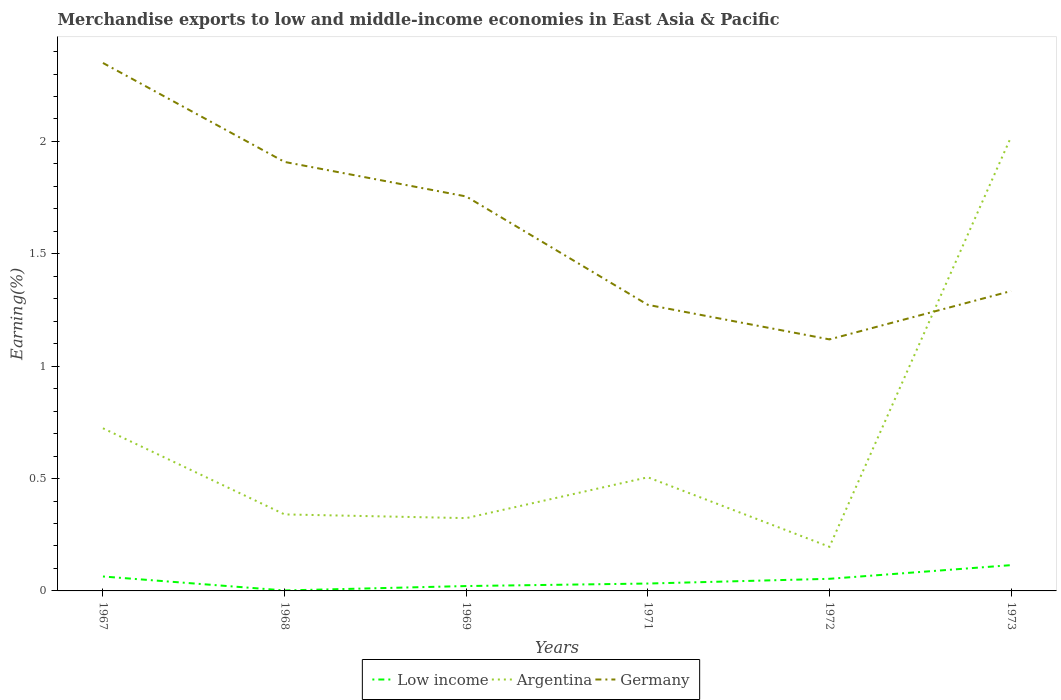Does the line corresponding to Argentina intersect with the line corresponding to Low income?
Make the answer very short. No. Is the number of lines equal to the number of legend labels?
Provide a succinct answer. Yes. Across all years, what is the maximum percentage of amount earned from merchandise exports in Germany?
Provide a short and direct response. 1.12. In which year was the percentage of amount earned from merchandise exports in Low income maximum?
Offer a terse response. 1968. What is the total percentage of amount earned from merchandise exports in Argentina in the graph?
Keep it short and to the point. -0.17. What is the difference between the highest and the second highest percentage of amount earned from merchandise exports in Argentina?
Your response must be concise. 1.82. What is the difference between the highest and the lowest percentage of amount earned from merchandise exports in Argentina?
Make the answer very short. 2. Is the percentage of amount earned from merchandise exports in Germany strictly greater than the percentage of amount earned from merchandise exports in Low income over the years?
Your answer should be very brief. No. How many lines are there?
Offer a very short reply. 3. Does the graph contain grids?
Keep it short and to the point. No. Where does the legend appear in the graph?
Offer a very short reply. Bottom center. What is the title of the graph?
Your answer should be very brief. Merchandise exports to low and middle-income economies in East Asia & Pacific. What is the label or title of the Y-axis?
Offer a terse response. Earning(%). What is the Earning(%) in Low income in 1967?
Keep it short and to the point. 0.06. What is the Earning(%) in Argentina in 1967?
Keep it short and to the point. 0.72. What is the Earning(%) of Germany in 1967?
Give a very brief answer. 2.35. What is the Earning(%) of Low income in 1968?
Provide a succinct answer. 0. What is the Earning(%) in Argentina in 1968?
Keep it short and to the point. 0.34. What is the Earning(%) of Germany in 1968?
Your response must be concise. 1.91. What is the Earning(%) in Low income in 1969?
Provide a succinct answer. 0.02. What is the Earning(%) of Argentina in 1969?
Keep it short and to the point. 0.32. What is the Earning(%) in Germany in 1969?
Keep it short and to the point. 1.76. What is the Earning(%) in Low income in 1971?
Offer a very short reply. 0.03. What is the Earning(%) in Argentina in 1971?
Ensure brevity in your answer.  0.51. What is the Earning(%) in Germany in 1971?
Your answer should be very brief. 1.27. What is the Earning(%) in Low income in 1972?
Provide a short and direct response. 0.05. What is the Earning(%) in Argentina in 1972?
Provide a succinct answer. 0.2. What is the Earning(%) in Germany in 1972?
Give a very brief answer. 1.12. What is the Earning(%) of Low income in 1973?
Provide a succinct answer. 0.11. What is the Earning(%) of Argentina in 1973?
Offer a terse response. 2.02. What is the Earning(%) in Germany in 1973?
Give a very brief answer. 1.33. Across all years, what is the maximum Earning(%) of Low income?
Ensure brevity in your answer.  0.11. Across all years, what is the maximum Earning(%) of Argentina?
Keep it short and to the point. 2.02. Across all years, what is the maximum Earning(%) of Germany?
Your answer should be compact. 2.35. Across all years, what is the minimum Earning(%) in Low income?
Ensure brevity in your answer.  0. Across all years, what is the minimum Earning(%) in Argentina?
Offer a terse response. 0.2. Across all years, what is the minimum Earning(%) of Germany?
Offer a very short reply. 1.12. What is the total Earning(%) of Low income in the graph?
Your answer should be compact. 0.29. What is the total Earning(%) in Argentina in the graph?
Your response must be concise. 4.11. What is the total Earning(%) of Germany in the graph?
Your answer should be very brief. 9.74. What is the difference between the Earning(%) of Low income in 1967 and that in 1968?
Keep it short and to the point. 0.06. What is the difference between the Earning(%) of Argentina in 1967 and that in 1968?
Provide a short and direct response. 0.38. What is the difference between the Earning(%) in Germany in 1967 and that in 1968?
Keep it short and to the point. 0.44. What is the difference between the Earning(%) in Low income in 1967 and that in 1969?
Your answer should be compact. 0.04. What is the difference between the Earning(%) in Argentina in 1967 and that in 1969?
Ensure brevity in your answer.  0.4. What is the difference between the Earning(%) in Germany in 1967 and that in 1969?
Provide a succinct answer. 0.59. What is the difference between the Earning(%) in Low income in 1967 and that in 1971?
Provide a short and direct response. 0.03. What is the difference between the Earning(%) of Argentina in 1967 and that in 1971?
Your answer should be very brief. 0.22. What is the difference between the Earning(%) of Germany in 1967 and that in 1971?
Offer a terse response. 1.08. What is the difference between the Earning(%) in Low income in 1967 and that in 1972?
Your answer should be very brief. 0.01. What is the difference between the Earning(%) of Argentina in 1967 and that in 1972?
Your answer should be very brief. 0.53. What is the difference between the Earning(%) in Germany in 1967 and that in 1972?
Provide a succinct answer. 1.23. What is the difference between the Earning(%) in Low income in 1967 and that in 1973?
Offer a very short reply. -0.05. What is the difference between the Earning(%) of Argentina in 1967 and that in 1973?
Offer a terse response. -1.3. What is the difference between the Earning(%) of Germany in 1967 and that in 1973?
Your answer should be very brief. 1.01. What is the difference between the Earning(%) in Low income in 1968 and that in 1969?
Your answer should be very brief. -0.02. What is the difference between the Earning(%) in Argentina in 1968 and that in 1969?
Your answer should be very brief. 0.02. What is the difference between the Earning(%) of Germany in 1968 and that in 1969?
Provide a short and direct response. 0.15. What is the difference between the Earning(%) of Low income in 1968 and that in 1971?
Offer a terse response. -0.03. What is the difference between the Earning(%) in Argentina in 1968 and that in 1971?
Your response must be concise. -0.17. What is the difference between the Earning(%) in Germany in 1968 and that in 1971?
Provide a succinct answer. 0.64. What is the difference between the Earning(%) of Low income in 1968 and that in 1972?
Provide a short and direct response. -0.05. What is the difference between the Earning(%) in Argentina in 1968 and that in 1972?
Offer a terse response. 0.14. What is the difference between the Earning(%) of Germany in 1968 and that in 1972?
Keep it short and to the point. 0.79. What is the difference between the Earning(%) of Low income in 1968 and that in 1973?
Make the answer very short. -0.11. What is the difference between the Earning(%) of Argentina in 1968 and that in 1973?
Offer a very short reply. -1.68. What is the difference between the Earning(%) in Germany in 1968 and that in 1973?
Your answer should be very brief. 0.57. What is the difference between the Earning(%) of Low income in 1969 and that in 1971?
Offer a very short reply. -0.01. What is the difference between the Earning(%) in Argentina in 1969 and that in 1971?
Make the answer very short. -0.18. What is the difference between the Earning(%) in Germany in 1969 and that in 1971?
Ensure brevity in your answer.  0.48. What is the difference between the Earning(%) in Low income in 1969 and that in 1972?
Your answer should be compact. -0.03. What is the difference between the Earning(%) in Argentina in 1969 and that in 1972?
Provide a succinct answer. 0.13. What is the difference between the Earning(%) in Germany in 1969 and that in 1972?
Your response must be concise. 0.64. What is the difference between the Earning(%) of Low income in 1969 and that in 1973?
Your response must be concise. -0.09. What is the difference between the Earning(%) in Argentina in 1969 and that in 1973?
Provide a short and direct response. -1.7. What is the difference between the Earning(%) in Germany in 1969 and that in 1973?
Give a very brief answer. 0.42. What is the difference between the Earning(%) in Low income in 1971 and that in 1972?
Give a very brief answer. -0.02. What is the difference between the Earning(%) of Argentina in 1971 and that in 1972?
Your answer should be very brief. 0.31. What is the difference between the Earning(%) of Germany in 1971 and that in 1972?
Your response must be concise. 0.15. What is the difference between the Earning(%) in Low income in 1971 and that in 1973?
Offer a very short reply. -0.08. What is the difference between the Earning(%) of Argentina in 1971 and that in 1973?
Give a very brief answer. -1.51. What is the difference between the Earning(%) of Germany in 1971 and that in 1973?
Make the answer very short. -0.06. What is the difference between the Earning(%) of Low income in 1972 and that in 1973?
Ensure brevity in your answer.  -0.06. What is the difference between the Earning(%) in Argentina in 1972 and that in 1973?
Your answer should be compact. -1.82. What is the difference between the Earning(%) of Germany in 1972 and that in 1973?
Make the answer very short. -0.22. What is the difference between the Earning(%) in Low income in 1967 and the Earning(%) in Argentina in 1968?
Ensure brevity in your answer.  -0.28. What is the difference between the Earning(%) in Low income in 1967 and the Earning(%) in Germany in 1968?
Your response must be concise. -1.84. What is the difference between the Earning(%) in Argentina in 1967 and the Earning(%) in Germany in 1968?
Make the answer very short. -1.19. What is the difference between the Earning(%) of Low income in 1967 and the Earning(%) of Argentina in 1969?
Keep it short and to the point. -0.26. What is the difference between the Earning(%) in Low income in 1967 and the Earning(%) in Germany in 1969?
Ensure brevity in your answer.  -1.69. What is the difference between the Earning(%) of Argentina in 1967 and the Earning(%) of Germany in 1969?
Make the answer very short. -1.03. What is the difference between the Earning(%) of Low income in 1967 and the Earning(%) of Argentina in 1971?
Give a very brief answer. -0.44. What is the difference between the Earning(%) in Low income in 1967 and the Earning(%) in Germany in 1971?
Give a very brief answer. -1.21. What is the difference between the Earning(%) of Argentina in 1967 and the Earning(%) of Germany in 1971?
Your response must be concise. -0.55. What is the difference between the Earning(%) of Low income in 1967 and the Earning(%) of Argentina in 1972?
Your answer should be very brief. -0.13. What is the difference between the Earning(%) in Low income in 1967 and the Earning(%) in Germany in 1972?
Your answer should be compact. -1.05. What is the difference between the Earning(%) of Argentina in 1967 and the Earning(%) of Germany in 1972?
Make the answer very short. -0.4. What is the difference between the Earning(%) of Low income in 1967 and the Earning(%) of Argentina in 1973?
Offer a terse response. -1.96. What is the difference between the Earning(%) in Low income in 1967 and the Earning(%) in Germany in 1973?
Make the answer very short. -1.27. What is the difference between the Earning(%) of Argentina in 1967 and the Earning(%) of Germany in 1973?
Provide a short and direct response. -0.61. What is the difference between the Earning(%) in Low income in 1968 and the Earning(%) in Argentina in 1969?
Your response must be concise. -0.32. What is the difference between the Earning(%) in Low income in 1968 and the Earning(%) in Germany in 1969?
Ensure brevity in your answer.  -1.75. What is the difference between the Earning(%) of Argentina in 1968 and the Earning(%) of Germany in 1969?
Your answer should be compact. -1.41. What is the difference between the Earning(%) of Low income in 1968 and the Earning(%) of Argentina in 1971?
Ensure brevity in your answer.  -0.5. What is the difference between the Earning(%) in Low income in 1968 and the Earning(%) in Germany in 1971?
Give a very brief answer. -1.27. What is the difference between the Earning(%) of Argentina in 1968 and the Earning(%) of Germany in 1971?
Your answer should be compact. -0.93. What is the difference between the Earning(%) of Low income in 1968 and the Earning(%) of Argentina in 1972?
Your answer should be compact. -0.19. What is the difference between the Earning(%) in Low income in 1968 and the Earning(%) in Germany in 1972?
Offer a terse response. -1.12. What is the difference between the Earning(%) of Argentina in 1968 and the Earning(%) of Germany in 1972?
Offer a very short reply. -0.78. What is the difference between the Earning(%) of Low income in 1968 and the Earning(%) of Argentina in 1973?
Offer a terse response. -2.02. What is the difference between the Earning(%) in Low income in 1968 and the Earning(%) in Germany in 1973?
Ensure brevity in your answer.  -1.33. What is the difference between the Earning(%) of Argentina in 1968 and the Earning(%) of Germany in 1973?
Keep it short and to the point. -0.99. What is the difference between the Earning(%) of Low income in 1969 and the Earning(%) of Argentina in 1971?
Your response must be concise. -0.48. What is the difference between the Earning(%) of Low income in 1969 and the Earning(%) of Germany in 1971?
Your answer should be very brief. -1.25. What is the difference between the Earning(%) of Argentina in 1969 and the Earning(%) of Germany in 1971?
Offer a terse response. -0.95. What is the difference between the Earning(%) of Low income in 1969 and the Earning(%) of Argentina in 1972?
Give a very brief answer. -0.17. What is the difference between the Earning(%) in Low income in 1969 and the Earning(%) in Germany in 1972?
Give a very brief answer. -1.1. What is the difference between the Earning(%) of Argentina in 1969 and the Earning(%) of Germany in 1972?
Provide a short and direct response. -0.8. What is the difference between the Earning(%) of Low income in 1969 and the Earning(%) of Argentina in 1973?
Provide a succinct answer. -2. What is the difference between the Earning(%) in Low income in 1969 and the Earning(%) in Germany in 1973?
Make the answer very short. -1.31. What is the difference between the Earning(%) in Argentina in 1969 and the Earning(%) in Germany in 1973?
Your answer should be compact. -1.01. What is the difference between the Earning(%) in Low income in 1971 and the Earning(%) in Argentina in 1972?
Keep it short and to the point. -0.16. What is the difference between the Earning(%) in Low income in 1971 and the Earning(%) in Germany in 1972?
Make the answer very short. -1.09. What is the difference between the Earning(%) of Argentina in 1971 and the Earning(%) of Germany in 1972?
Your answer should be very brief. -0.61. What is the difference between the Earning(%) in Low income in 1971 and the Earning(%) in Argentina in 1973?
Your response must be concise. -1.99. What is the difference between the Earning(%) of Low income in 1971 and the Earning(%) of Germany in 1973?
Your response must be concise. -1.3. What is the difference between the Earning(%) of Argentina in 1971 and the Earning(%) of Germany in 1973?
Your answer should be very brief. -0.83. What is the difference between the Earning(%) of Low income in 1972 and the Earning(%) of Argentina in 1973?
Your answer should be very brief. -1.97. What is the difference between the Earning(%) in Low income in 1972 and the Earning(%) in Germany in 1973?
Your answer should be compact. -1.28. What is the difference between the Earning(%) in Argentina in 1972 and the Earning(%) in Germany in 1973?
Offer a very short reply. -1.14. What is the average Earning(%) in Low income per year?
Offer a terse response. 0.05. What is the average Earning(%) of Argentina per year?
Offer a very short reply. 0.69. What is the average Earning(%) in Germany per year?
Your answer should be compact. 1.62. In the year 1967, what is the difference between the Earning(%) of Low income and Earning(%) of Argentina?
Keep it short and to the point. -0.66. In the year 1967, what is the difference between the Earning(%) of Low income and Earning(%) of Germany?
Give a very brief answer. -2.29. In the year 1967, what is the difference between the Earning(%) in Argentina and Earning(%) in Germany?
Give a very brief answer. -1.63. In the year 1968, what is the difference between the Earning(%) in Low income and Earning(%) in Argentina?
Ensure brevity in your answer.  -0.34. In the year 1968, what is the difference between the Earning(%) in Low income and Earning(%) in Germany?
Your answer should be compact. -1.91. In the year 1968, what is the difference between the Earning(%) in Argentina and Earning(%) in Germany?
Offer a very short reply. -1.57. In the year 1969, what is the difference between the Earning(%) of Low income and Earning(%) of Argentina?
Give a very brief answer. -0.3. In the year 1969, what is the difference between the Earning(%) of Low income and Earning(%) of Germany?
Your response must be concise. -1.73. In the year 1969, what is the difference between the Earning(%) of Argentina and Earning(%) of Germany?
Make the answer very short. -1.43. In the year 1971, what is the difference between the Earning(%) of Low income and Earning(%) of Argentina?
Keep it short and to the point. -0.47. In the year 1971, what is the difference between the Earning(%) in Low income and Earning(%) in Germany?
Provide a succinct answer. -1.24. In the year 1971, what is the difference between the Earning(%) in Argentina and Earning(%) in Germany?
Provide a short and direct response. -0.77. In the year 1972, what is the difference between the Earning(%) of Low income and Earning(%) of Argentina?
Make the answer very short. -0.14. In the year 1972, what is the difference between the Earning(%) of Low income and Earning(%) of Germany?
Provide a short and direct response. -1.07. In the year 1972, what is the difference between the Earning(%) in Argentina and Earning(%) in Germany?
Give a very brief answer. -0.92. In the year 1973, what is the difference between the Earning(%) of Low income and Earning(%) of Argentina?
Provide a succinct answer. -1.91. In the year 1973, what is the difference between the Earning(%) in Low income and Earning(%) in Germany?
Ensure brevity in your answer.  -1.22. In the year 1973, what is the difference between the Earning(%) in Argentina and Earning(%) in Germany?
Offer a terse response. 0.69. What is the ratio of the Earning(%) in Low income in 1967 to that in 1968?
Offer a terse response. 30.75. What is the ratio of the Earning(%) of Argentina in 1967 to that in 1968?
Provide a short and direct response. 2.13. What is the ratio of the Earning(%) in Germany in 1967 to that in 1968?
Provide a succinct answer. 1.23. What is the ratio of the Earning(%) in Low income in 1967 to that in 1969?
Offer a very short reply. 2.96. What is the ratio of the Earning(%) of Argentina in 1967 to that in 1969?
Keep it short and to the point. 2.23. What is the ratio of the Earning(%) in Germany in 1967 to that in 1969?
Your answer should be compact. 1.34. What is the ratio of the Earning(%) of Low income in 1967 to that in 1971?
Provide a succinct answer. 1.95. What is the ratio of the Earning(%) in Argentina in 1967 to that in 1971?
Your response must be concise. 1.43. What is the ratio of the Earning(%) in Germany in 1967 to that in 1971?
Keep it short and to the point. 1.85. What is the ratio of the Earning(%) in Low income in 1967 to that in 1972?
Provide a succinct answer. 1.19. What is the ratio of the Earning(%) in Argentina in 1967 to that in 1972?
Offer a terse response. 3.69. What is the ratio of the Earning(%) of Germany in 1967 to that in 1972?
Provide a short and direct response. 2.1. What is the ratio of the Earning(%) in Low income in 1967 to that in 1973?
Make the answer very short. 0.56. What is the ratio of the Earning(%) of Argentina in 1967 to that in 1973?
Provide a succinct answer. 0.36. What is the ratio of the Earning(%) of Germany in 1967 to that in 1973?
Keep it short and to the point. 1.76. What is the ratio of the Earning(%) of Low income in 1968 to that in 1969?
Your answer should be very brief. 0.1. What is the ratio of the Earning(%) in Argentina in 1968 to that in 1969?
Make the answer very short. 1.05. What is the ratio of the Earning(%) in Germany in 1968 to that in 1969?
Ensure brevity in your answer.  1.09. What is the ratio of the Earning(%) in Low income in 1968 to that in 1971?
Your response must be concise. 0.06. What is the ratio of the Earning(%) of Argentina in 1968 to that in 1971?
Provide a short and direct response. 0.67. What is the ratio of the Earning(%) of Germany in 1968 to that in 1971?
Your answer should be very brief. 1.5. What is the ratio of the Earning(%) in Low income in 1968 to that in 1972?
Make the answer very short. 0.04. What is the ratio of the Earning(%) in Argentina in 1968 to that in 1972?
Make the answer very short. 1.73. What is the ratio of the Earning(%) of Germany in 1968 to that in 1972?
Your answer should be very brief. 1.71. What is the ratio of the Earning(%) in Low income in 1968 to that in 1973?
Offer a terse response. 0.02. What is the ratio of the Earning(%) of Argentina in 1968 to that in 1973?
Offer a terse response. 0.17. What is the ratio of the Earning(%) of Germany in 1968 to that in 1973?
Your response must be concise. 1.43. What is the ratio of the Earning(%) of Low income in 1969 to that in 1971?
Provide a short and direct response. 0.66. What is the ratio of the Earning(%) of Argentina in 1969 to that in 1971?
Make the answer very short. 0.64. What is the ratio of the Earning(%) in Germany in 1969 to that in 1971?
Your answer should be very brief. 1.38. What is the ratio of the Earning(%) in Low income in 1969 to that in 1972?
Keep it short and to the point. 0.4. What is the ratio of the Earning(%) in Argentina in 1969 to that in 1972?
Offer a very short reply. 1.65. What is the ratio of the Earning(%) of Germany in 1969 to that in 1972?
Keep it short and to the point. 1.57. What is the ratio of the Earning(%) in Low income in 1969 to that in 1973?
Your response must be concise. 0.19. What is the ratio of the Earning(%) of Argentina in 1969 to that in 1973?
Make the answer very short. 0.16. What is the ratio of the Earning(%) in Germany in 1969 to that in 1973?
Your response must be concise. 1.32. What is the ratio of the Earning(%) of Low income in 1971 to that in 1972?
Provide a succinct answer. 0.61. What is the ratio of the Earning(%) of Argentina in 1971 to that in 1972?
Keep it short and to the point. 2.58. What is the ratio of the Earning(%) in Germany in 1971 to that in 1972?
Offer a terse response. 1.14. What is the ratio of the Earning(%) of Low income in 1971 to that in 1973?
Ensure brevity in your answer.  0.29. What is the ratio of the Earning(%) in Argentina in 1971 to that in 1973?
Provide a short and direct response. 0.25. What is the ratio of the Earning(%) of Germany in 1971 to that in 1973?
Provide a short and direct response. 0.95. What is the ratio of the Earning(%) in Low income in 1972 to that in 1973?
Ensure brevity in your answer.  0.47. What is the ratio of the Earning(%) in Argentina in 1972 to that in 1973?
Your answer should be compact. 0.1. What is the ratio of the Earning(%) in Germany in 1972 to that in 1973?
Provide a short and direct response. 0.84. What is the difference between the highest and the second highest Earning(%) of Low income?
Make the answer very short. 0.05. What is the difference between the highest and the second highest Earning(%) of Argentina?
Provide a succinct answer. 1.3. What is the difference between the highest and the second highest Earning(%) in Germany?
Your answer should be compact. 0.44. What is the difference between the highest and the lowest Earning(%) in Low income?
Provide a short and direct response. 0.11. What is the difference between the highest and the lowest Earning(%) in Argentina?
Offer a terse response. 1.82. What is the difference between the highest and the lowest Earning(%) of Germany?
Provide a succinct answer. 1.23. 